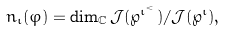<formula> <loc_0><loc_0><loc_500><loc_500>n _ { \iota } ( \varphi ) = \dim _ { \mathbb { C } } { \mathcal { J } } ( \wp ^ { \iota ^ { < } } ) / { \mathcal { J } } ( \wp ^ { \iota } ) ,</formula> 